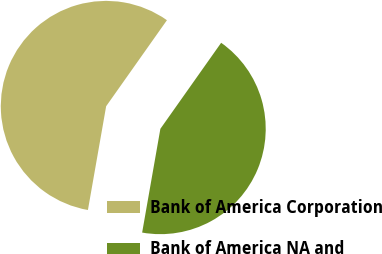Convert chart. <chart><loc_0><loc_0><loc_500><loc_500><pie_chart><fcel>Bank of America Corporation<fcel>Bank of America NA and<nl><fcel>57.02%<fcel>42.98%<nl></chart> 